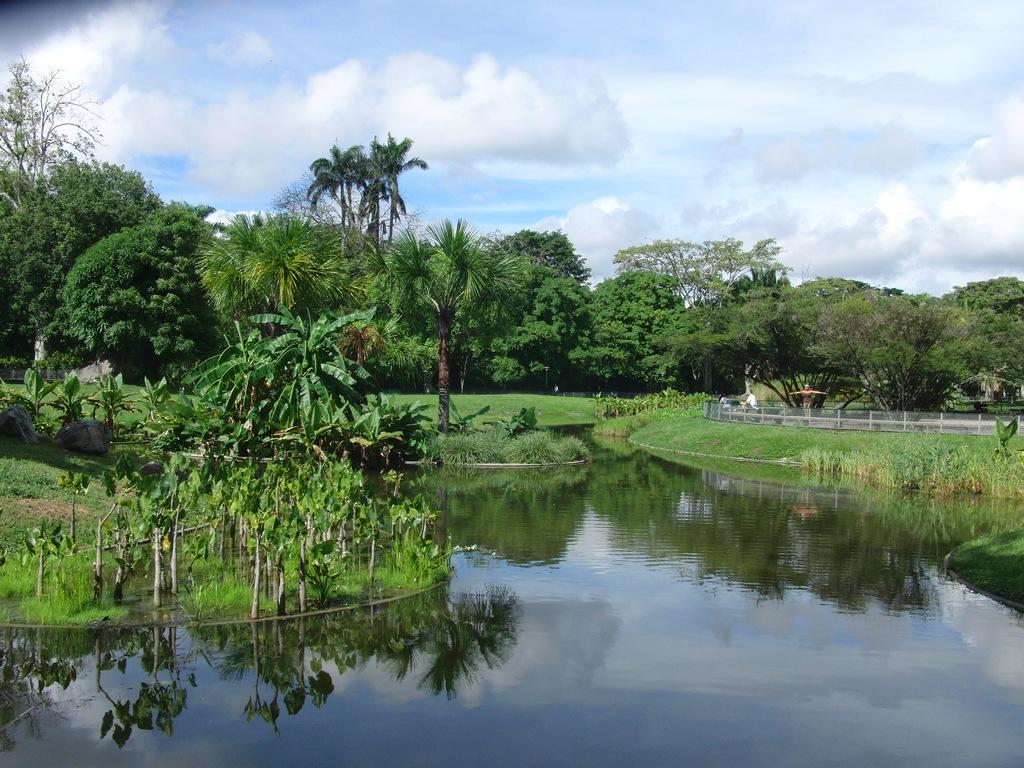What type of vegetation can be seen in the image? There are trees in the image. What type of barrier is present in the image? There is a fence in the image. What can be seen at the bottom of the image? There is water visible at the bottom of the image. What is visible in the background of the image? The sky is visible in the background of the image. What type of straw is being used by the minister in the image? There is no minister or straw present in the image. What type of engine can be seen powering the vehicle in the image? There is no vehicle or engine present in the image. 